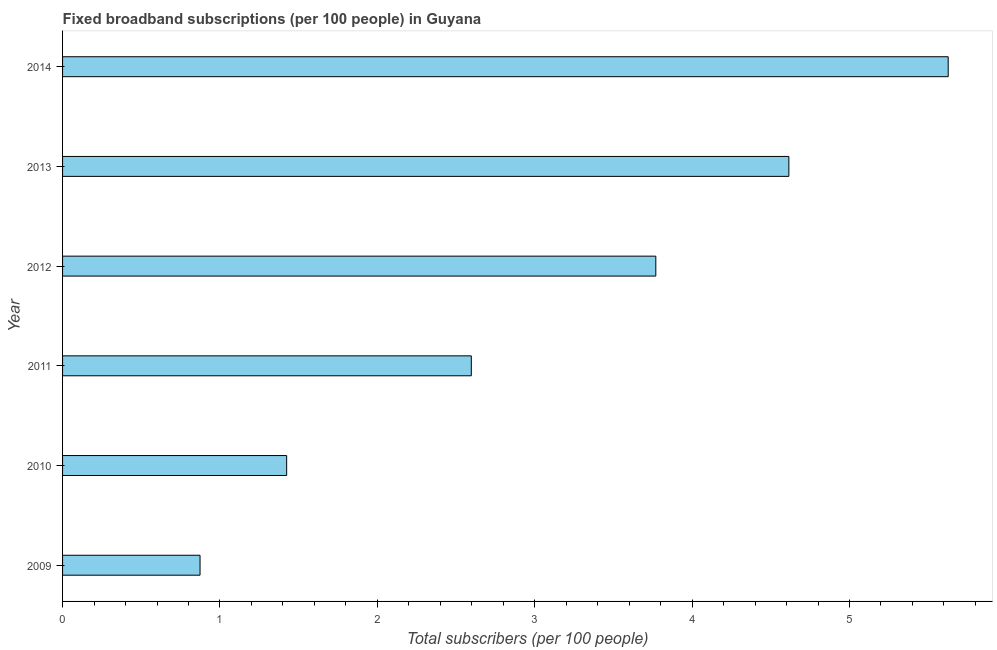Does the graph contain any zero values?
Offer a terse response. No. Does the graph contain grids?
Your response must be concise. No. What is the title of the graph?
Ensure brevity in your answer.  Fixed broadband subscriptions (per 100 people) in Guyana. What is the label or title of the X-axis?
Your answer should be compact. Total subscribers (per 100 people). What is the total number of fixed broadband subscriptions in 2014?
Your response must be concise. 5.63. Across all years, what is the maximum total number of fixed broadband subscriptions?
Offer a very short reply. 5.63. Across all years, what is the minimum total number of fixed broadband subscriptions?
Ensure brevity in your answer.  0.87. In which year was the total number of fixed broadband subscriptions maximum?
Make the answer very short. 2014. What is the sum of the total number of fixed broadband subscriptions?
Give a very brief answer. 18.91. What is the difference between the total number of fixed broadband subscriptions in 2012 and 2014?
Your response must be concise. -1.86. What is the average total number of fixed broadband subscriptions per year?
Provide a succinct answer. 3.15. What is the median total number of fixed broadband subscriptions?
Ensure brevity in your answer.  3.18. What is the ratio of the total number of fixed broadband subscriptions in 2010 to that in 2012?
Your response must be concise. 0.38. Is the total number of fixed broadband subscriptions in 2012 less than that in 2014?
Offer a very short reply. Yes. What is the difference between the highest and the second highest total number of fixed broadband subscriptions?
Your response must be concise. 1.01. What is the difference between the highest and the lowest total number of fixed broadband subscriptions?
Your answer should be compact. 4.75. How many bars are there?
Offer a terse response. 6. How many years are there in the graph?
Ensure brevity in your answer.  6. Are the values on the major ticks of X-axis written in scientific E-notation?
Offer a very short reply. No. What is the Total subscribers (per 100 people) in 2009?
Provide a short and direct response. 0.87. What is the Total subscribers (per 100 people) of 2010?
Offer a terse response. 1.42. What is the Total subscribers (per 100 people) in 2011?
Your response must be concise. 2.6. What is the Total subscribers (per 100 people) of 2012?
Make the answer very short. 3.77. What is the Total subscribers (per 100 people) in 2013?
Provide a succinct answer. 4.61. What is the Total subscribers (per 100 people) of 2014?
Your response must be concise. 5.63. What is the difference between the Total subscribers (per 100 people) in 2009 and 2010?
Your answer should be compact. -0.55. What is the difference between the Total subscribers (per 100 people) in 2009 and 2011?
Provide a succinct answer. -1.72. What is the difference between the Total subscribers (per 100 people) in 2009 and 2012?
Your answer should be compact. -2.9. What is the difference between the Total subscribers (per 100 people) in 2009 and 2013?
Give a very brief answer. -3.74. What is the difference between the Total subscribers (per 100 people) in 2009 and 2014?
Provide a succinct answer. -4.75. What is the difference between the Total subscribers (per 100 people) in 2010 and 2011?
Offer a very short reply. -1.17. What is the difference between the Total subscribers (per 100 people) in 2010 and 2012?
Keep it short and to the point. -2.35. What is the difference between the Total subscribers (per 100 people) in 2010 and 2013?
Offer a terse response. -3.19. What is the difference between the Total subscribers (per 100 people) in 2010 and 2014?
Ensure brevity in your answer.  -4.2. What is the difference between the Total subscribers (per 100 people) in 2011 and 2012?
Your answer should be very brief. -1.17. What is the difference between the Total subscribers (per 100 people) in 2011 and 2013?
Your response must be concise. -2.02. What is the difference between the Total subscribers (per 100 people) in 2011 and 2014?
Your response must be concise. -3.03. What is the difference between the Total subscribers (per 100 people) in 2012 and 2013?
Your answer should be compact. -0.85. What is the difference between the Total subscribers (per 100 people) in 2012 and 2014?
Give a very brief answer. -1.86. What is the difference between the Total subscribers (per 100 people) in 2013 and 2014?
Provide a succinct answer. -1.01. What is the ratio of the Total subscribers (per 100 people) in 2009 to that in 2010?
Ensure brevity in your answer.  0.61. What is the ratio of the Total subscribers (per 100 people) in 2009 to that in 2011?
Make the answer very short. 0.34. What is the ratio of the Total subscribers (per 100 people) in 2009 to that in 2012?
Your answer should be very brief. 0.23. What is the ratio of the Total subscribers (per 100 people) in 2009 to that in 2013?
Keep it short and to the point. 0.19. What is the ratio of the Total subscribers (per 100 people) in 2009 to that in 2014?
Your answer should be very brief. 0.15. What is the ratio of the Total subscribers (per 100 people) in 2010 to that in 2011?
Offer a very short reply. 0.55. What is the ratio of the Total subscribers (per 100 people) in 2010 to that in 2012?
Offer a terse response. 0.38. What is the ratio of the Total subscribers (per 100 people) in 2010 to that in 2013?
Provide a short and direct response. 0.31. What is the ratio of the Total subscribers (per 100 people) in 2010 to that in 2014?
Offer a very short reply. 0.25. What is the ratio of the Total subscribers (per 100 people) in 2011 to that in 2012?
Your answer should be very brief. 0.69. What is the ratio of the Total subscribers (per 100 people) in 2011 to that in 2013?
Keep it short and to the point. 0.56. What is the ratio of the Total subscribers (per 100 people) in 2011 to that in 2014?
Ensure brevity in your answer.  0.46. What is the ratio of the Total subscribers (per 100 people) in 2012 to that in 2013?
Your answer should be compact. 0.82. What is the ratio of the Total subscribers (per 100 people) in 2012 to that in 2014?
Make the answer very short. 0.67. What is the ratio of the Total subscribers (per 100 people) in 2013 to that in 2014?
Your answer should be very brief. 0.82. 